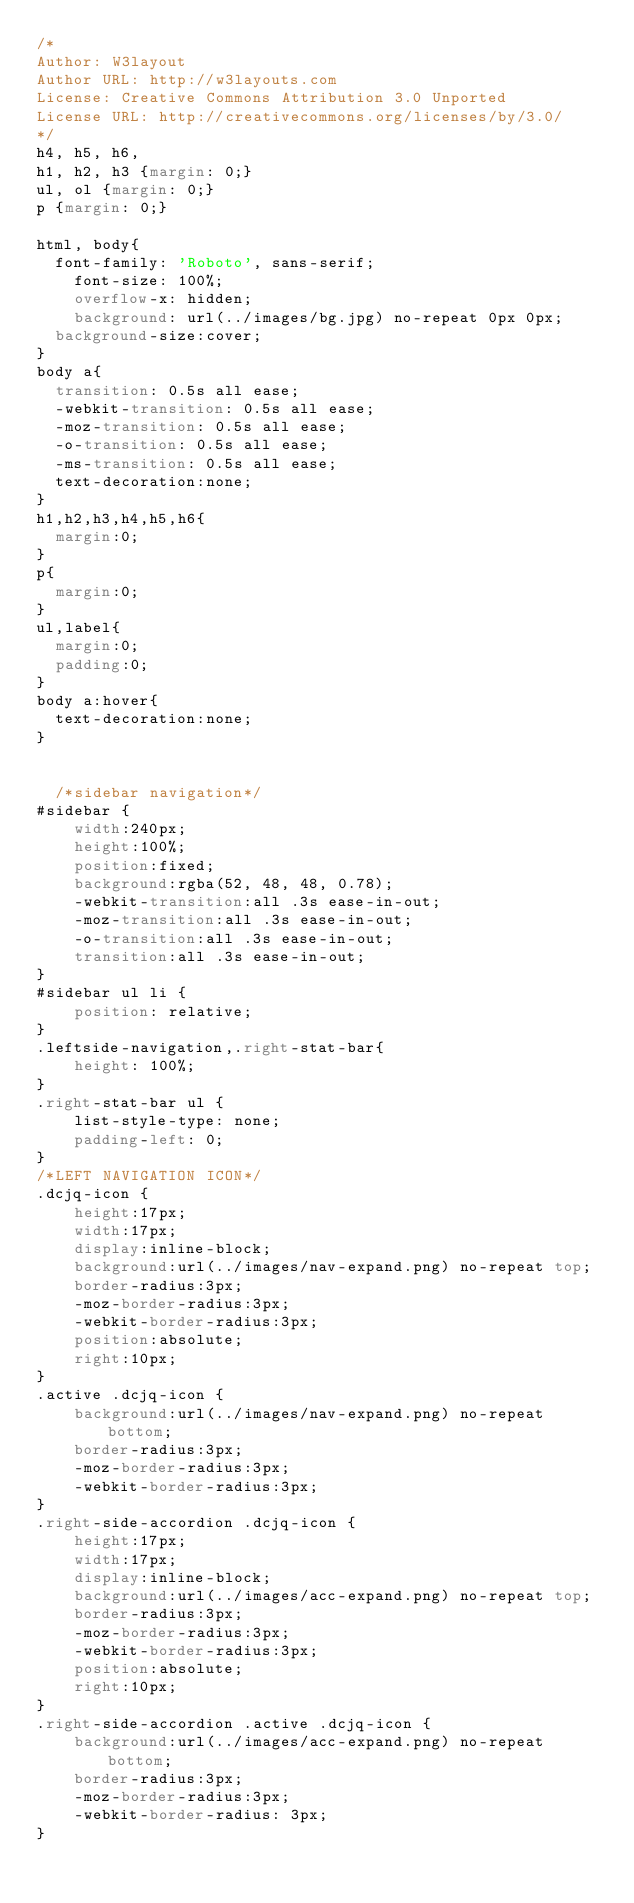Convert code to text. <code><loc_0><loc_0><loc_500><loc_500><_CSS_>/*
Author: W3layout
Author URL: http://w3layouts.com
License: Creative Commons Attribution 3.0 Unported
License URL: http://creativecommons.org/licenses/by/3.0/
*/
h4, h5, h6,
h1, h2, h3 {margin: 0;}
ul, ol {margin: 0;}
p {margin: 0;}

html, body{
	font-family: 'Roboto', sans-serif;
    font-size: 100%;
    overflow-x: hidden;
    background: url(../images/bg.jpg) no-repeat 0px 0px;
	background-size:cover;
}
body a{
	transition: 0.5s all ease;
	-webkit-transition: 0.5s all ease;
	-moz-transition: 0.5s all ease;
	-o-transition: 0.5s all ease;
	-ms-transition: 0.5s all ease;
	text-decoration:none;
}
h1,h2,h3,h4,h5,h6{
	margin:0;			   
}
p{
	margin:0;
}
ul,label{
	margin:0;
	padding:0;
}
body a:hover{
	text-decoration:none;
}


	/*sidebar navigation*/
#sidebar {
    width:240px;
    height:100%;
    position:fixed;
    background:rgba(52, 48, 48, 0.78);
    -webkit-transition:all .3s ease-in-out;
    -moz-transition:all .3s ease-in-out;
    -o-transition:all .3s ease-in-out;
    transition:all .3s ease-in-out;
}
#sidebar ul li {
    position: relative;
}
.leftside-navigation,.right-stat-bar{
    height: 100%;
}
.right-stat-bar ul {
    list-style-type: none;
    padding-left: 0;
}
/*LEFT NAVIGATION ICON*/
.dcjq-icon {
    height:17px;
    width:17px;
    display:inline-block;
    background:url(../images/nav-expand.png) no-repeat top;
    border-radius:3px;
    -moz-border-radius:3px;
    -webkit-border-radius:3px;
    position:absolute;
    right:10px;
}
.active .dcjq-icon {
    background:url(../images/nav-expand.png) no-repeat bottom;
    border-radius:3px;
    -moz-border-radius:3px;
    -webkit-border-radius:3px;
}
.right-side-accordion .dcjq-icon {
    height:17px;
    width:17px;
    display:inline-block;
    background:url(../images/acc-expand.png) no-repeat top;
    border-radius:3px;
    -moz-border-radius:3px;
    -webkit-border-radius:3px;
    position:absolute;
    right:10px;
}
.right-side-accordion .active .dcjq-icon {
    background:url(../images/acc-expand.png) no-repeat bottom;
    border-radius:3px;
    -moz-border-radius:3px;
    -webkit-border-radius: 3px;
}</code> 